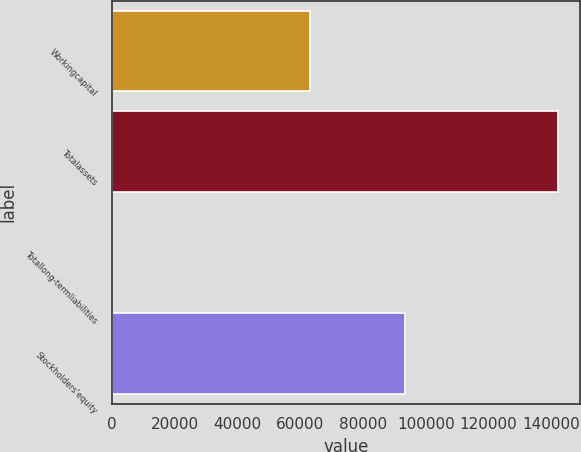Convert chart to OTSL. <chart><loc_0><loc_0><loc_500><loc_500><bar_chart><fcel>Workingcapital<fcel>Totalassets<fcel>Totallong-termliabilities<fcel>Stockholders'equity<nl><fcel>62978<fcel>142110<fcel>64<fcel>93438<nl></chart> 